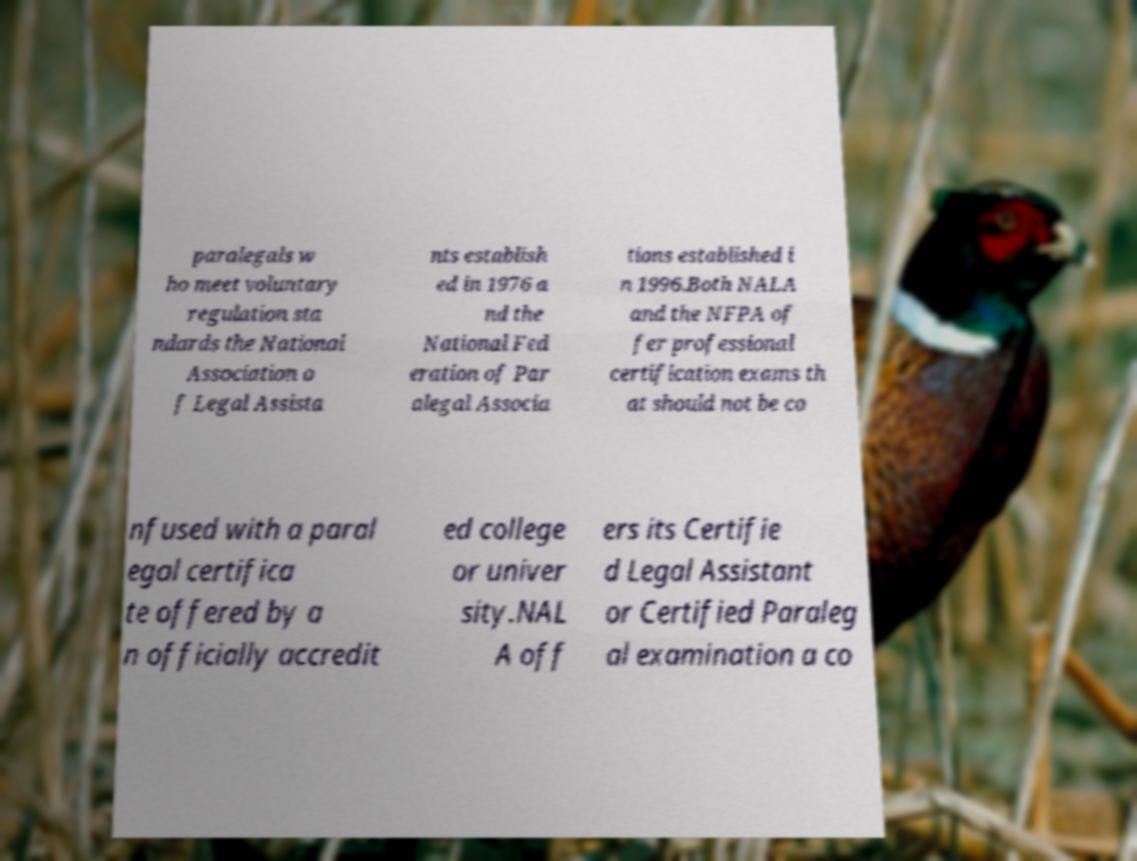What messages or text are displayed in this image? I need them in a readable, typed format. paralegals w ho meet voluntary regulation sta ndards the National Association o f Legal Assista nts establish ed in 1976 a nd the National Fed eration of Par alegal Associa tions established i n 1996.Both NALA and the NFPA of fer professional certification exams th at should not be co nfused with a paral egal certifica te offered by a n officially accredit ed college or univer sity.NAL A off ers its Certifie d Legal Assistant or Certified Paraleg al examination a co 